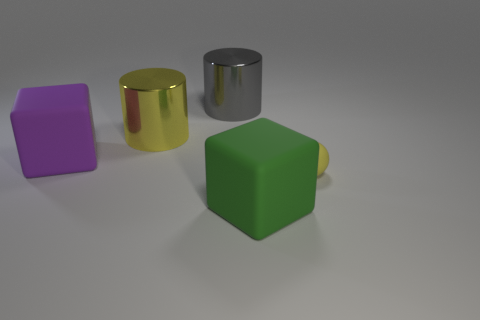Add 5 tiny matte spheres. How many objects exist? 10 Subtract all cylinders. How many objects are left? 3 Subtract 1 yellow cylinders. How many objects are left? 4 Subtract all big yellow shiny objects. Subtract all large yellow cylinders. How many objects are left? 3 Add 5 yellow shiny objects. How many yellow shiny objects are left? 6 Add 4 big gray metallic balls. How many big gray metallic balls exist? 4 